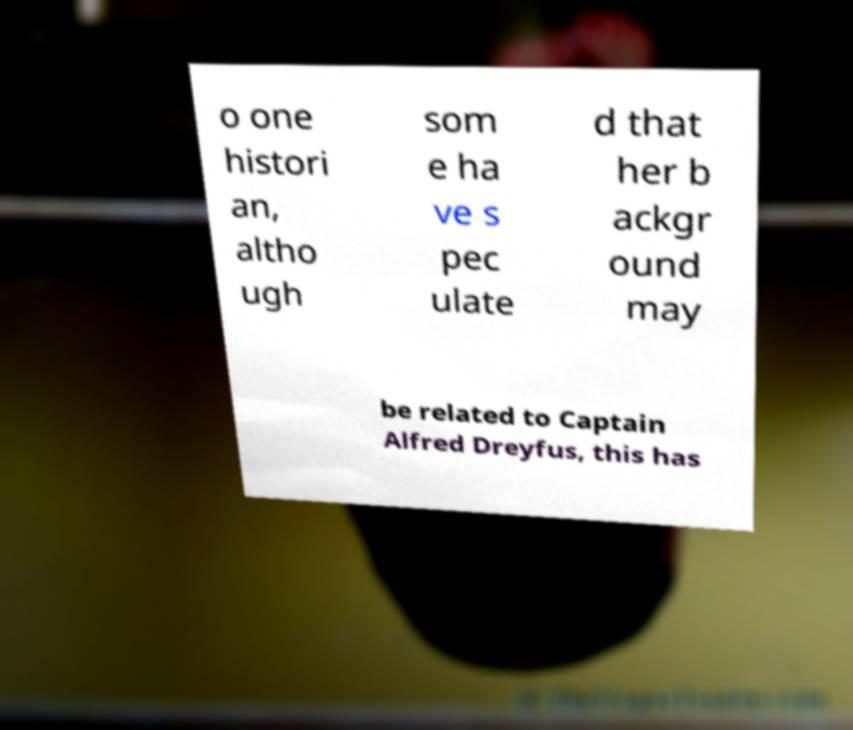Can you read and provide the text displayed in the image?This photo seems to have some interesting text. Can you extract and type it out for me? o one histori an, altho ugh som e ha ve s pec ulate d that her b ackgr ound may be related to Captain Alfred Dreyfus, this has 